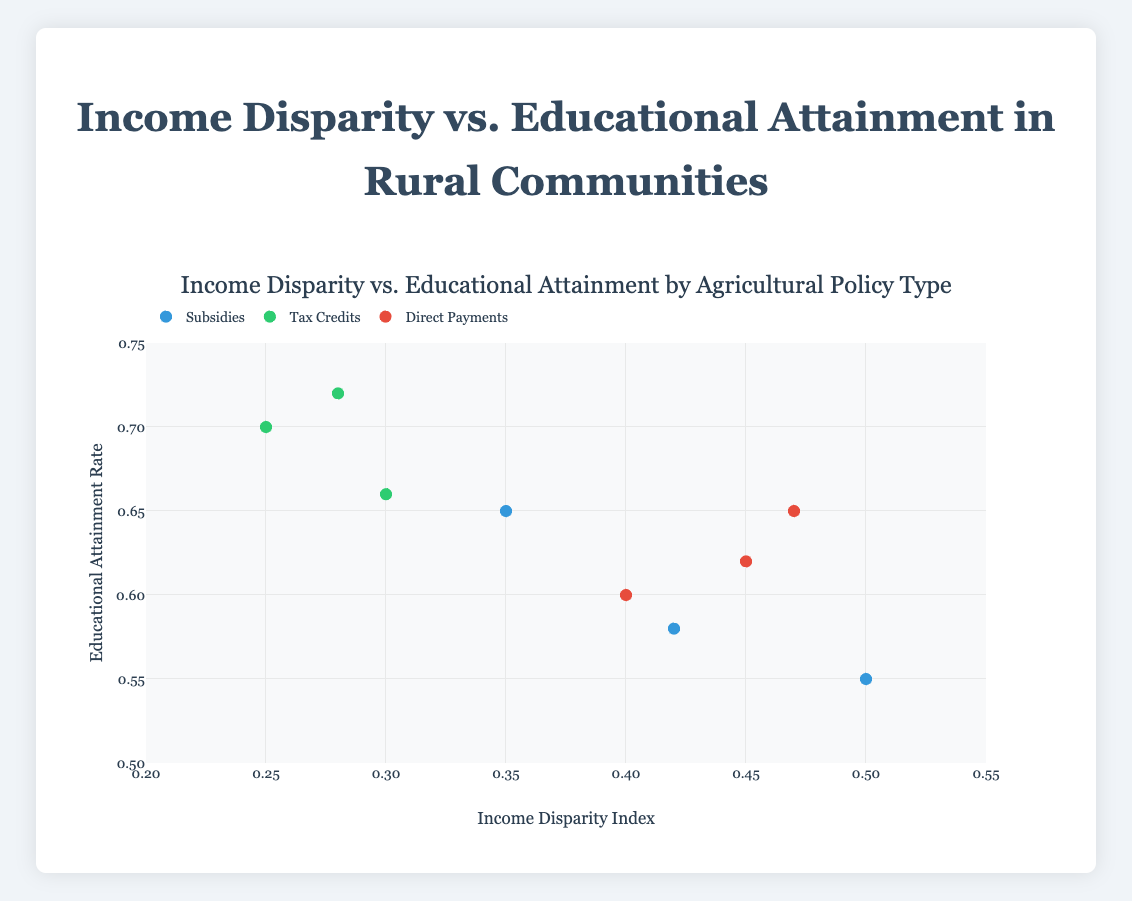Which community has the highest educational attainment rate under Tax Credits? In the Tax Credits group, the educational attainment rates are 0.70 (Hillcrest), 0.66 (Riverside), and 0.72 (Lakeside). Lakeside has the highest rate.
Answer: Lakeside What is the average income disparity index for communities under Direct Payments? The income disparity indices for Direct Payments are 0.40 (Mountain View), 0.45 (Pine Hill), and 0.47 (Redwood). Summing these gives 0.40 + 0.45 + 0.47 = 1.32 and averaging 1.32 / 3 = 0.44.
Answer: 0.44 Which type of agricultural policy is associated with the lowest median income disparity index? The median income disparity indices are: Subsidies (0.35, 0.42, 0.50 → median is 0.42), Tax Credits (0.25, 0.28, 0.30 → median is 0.28), and Direct Payments (0.40, 0.45, 0.47 → median is 0.45). The lowest median is for Tax Credits.
Answer: Tax Credits How many data points are represented in the plot? Each community represents a data point, with a total of 9 communities shown in the plot.
Answer: 9 Which community has the lowest income disparity index and what type of agricultural policy does it follow? The lowest income disparity index is 0.25 for Hillcrest, which follows Tax Credits.
Answer: Hillcrest, Tax Credits What is the relationship between educational attainment rate and income disparity index for communities under Subsidies? For communities under Subsidies, educational attainment rates are 0.65, 0.58, and 0.55 corresponding to income disparity indices of 0.35, 0.42, and 0.50, respectively. As the income disparity index increases, the educational attainment rate seems to decrease.
Answer: Negative relationship How does the average educational attainment rate differ between Subsidies and Direct Payments? The average educational attainment rate for Subsidies is (0.65 + 0.58 + 0.55) / 3 = 0.593, and for Direct Payments is (0.60 + 0.62 + 0.65) / 3 = 0.623. The difference is 0.623 - 0.593 = 0.03.
Answer: 0.03 What is the range of income disparity indices for communities under Tax Credits? The income disparity indices for Tax Credits are 0.25, 0.30, and 0.28. The range is 0.30 - 0.25 = 0.05.
Answer: 0.05 Which agricultural policy type is associated with the highest educational attainment rate? The highest educational attainment rate is 0.72 (Lakeside), which follows Tax Credits.
Answer: Tax Credits 